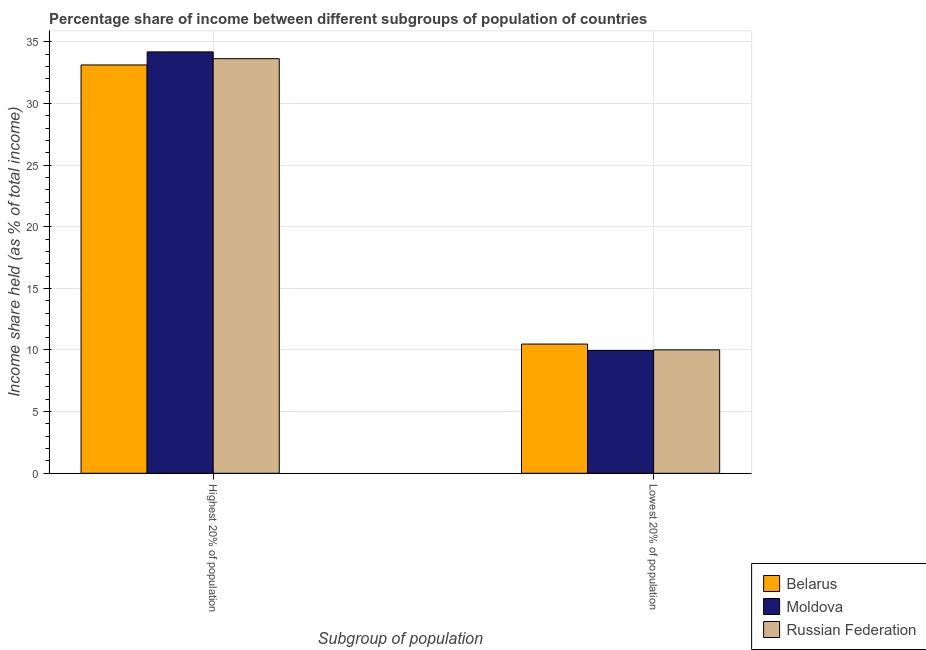How many different coloured bars are there?
Ensure brevity in your answer.  3. How many bars are there on the 1st tick from the left?
Your answer should be compact. 3. What is the label of the 1st group of bars from the left?
Ensure brevity in your answer.  Highest 20% of population. What is the income share held by highest 20% of the population in Moldova?
Your answer should be compact. 34.18. Across all countries, what is the maximum income share held by lowest 20% of the population?
Ensure brevity in your answer.  10.48. Across all countries, what is the minimum income share held by highest 20% of the population?
Make the answer very short. 33.12. In which country was the income share held by lowest 20% of the population maximum?
Make the answer very short. Belarus. In which country was the income share held by highest 20% of the population minimum?
Make the answer very short. Belarus. What is the total income share held by highest 20% of the population in the graph?
Keep it short and to the point. 100.93. What is the difference between the income share held by highest 20% of the population in Russian Federation and that in Moldova?
Provide a short and direct response. -0.55. What is the difference between the income share held by lowest 20% of the population in Russian Federation and the income share held by highest 20% of the population in Moldova?
Offer a very short reply. -24.17. What is the average income share held by lowest 20% of the population per country?
Offer a terse response. 10.15. What is the difference between the income share held by lowest 20% of the population and income share held by highest 20% of the population in Russian Federation?
Provide a succinct answer. -23.62. In how many countries, is the income share held by lowest 20% of the population greater than 13 %?
Provide a succinct answer. 0. What is the ratio of the income share held by highest 20% of the population in Russian Federation to that in Moldova?
Offer a very short reply. 0.98. Is the income share held by lowest 20% of the population in Russian Federation less than that in Belarus?
Offer a terse response. Yes. In how many countries, is the income share held by highest 20% of the population greater than the average income share held by highest 20% of the population taken over all countries?
Ensure brevity in your answer.  1. What does the 3rd bar from the left in Highest 20% of population represents?
Your response must be concise. Russian Federation. What does the 2nd bar from the right in Highest 20% of population represents?
Your response must be concise. Moldova. How many countries are there in the graph?
Keep it short and to the point. 3. Are the values on the major ticks of Y-axis written in scientific E-notation?
Keep it short and to the point. No. Does the graph contain any zero values?
Keep it short and to the point. No. Does the graph contain grids?
Offer a terse response. Yes. Where does the legend appear in the graph?
Your answer should be compact. Bottom right. How are the legend labels stacked?
Your answer should be compact. Vertical. What is the title of the graph?
Ensure brevity in your answer.  Percentage share of income between different subgroups of population of countries. Does "Caribbean small states" appear as one of the legend labels in the graph?
Keep it short and to the point. No. What is the label or title of the X-axis?
Your answer should be compact. Subgroup of population. What is the label or title of the Y-axis?
Offer a terse response. Income share held (as % of total income). What is the Income share held (as % of total income) in Belarus in Highest 20% of population?
Offer a very short reply. 33.12. What is the Income share held (as % of total income) of Moldova in Highest 20% of population?
Your answer should be very brief. 34.18. What is the Income share held (as % of total income) in Russian Federation in Highest 20% of population?
Offer a terse response. 33.63. What is the Income share held (as % of total income) in Belarus in Lowest 20% of population?
Your answer should be very brief. 10.48. What is the Income share held (as % of total income) in Moldova in Lowest 20% of population?
Give a very brief answer. 9.96. What is the Income share held (as % of total income) of Russian Federation in Lowest 20% of population?
Make the answer very short. 10.01. Across all Subgroup of population, what is the maximum Income share held (as % of total income) of Belarus?
Provide a succinct answer. 33.12. Across all Subgroup of population, what is the maximum Income share held (as % of total income) in Moldova?
Keep it short and to the point. 34.18. Across all Subgroup of population, what is the maximum Income share held (as % of total income) of Russian Federation?
Your answer should be very brief. 33.63. Across all Subgroup of population, what is the minimum Income share held (as % of total income) in Belarus?
Provide a short and direct response. 10.48. Across all Subgroup of population, what is the minimum Income share held (as % of total income) of Moldova?
Keep it short and to the point. 9.96. Across all Subgroup of population, what is the minimum Income share held (as % of total income) in Russian Federation?
Your answer should be compact. 10.01. What is the total Income share held (as % of total income) of Belarus in the graph?
Your answer should be very brief. 43.6. What is the total Income share held (as % of total income) in Moldova in the graph?
Provide a succinct answer. 44.14. What is the total Income share held (as % of total income) of Russian Federation in the graph?
Give a very brief answer. 43.64. What is the difference between the Income share held (as % of total income) in Belarus in Highest 20% of population and that in Lowest 20% of population?
Ensure brevity in your answer.  22.64. What is the difference between the Income share held (as % of total income) of Moldova in Highest 20% of population and that in Lowest 20% of population?
Give a very brief answer. 24.22. What is the difference between the Income share held (as % of total income) of Russian Federation in Highest 20% of population and that in Lowest 20% of population?
Provide a short and direct response. 23.62. What is the difference between the Income share held (as % of total income) of Belarus in Highest 20% of population and the Income share held (as % of total income) of Moldova in Lowest 20% of population?
Offer a terse response. 23.16. What is the difference between the Income share held (as % of total income) in Belarus in Highest 20% of population and the Income share held (as % of total income) in Russian Federation in Lowest 20% of population?
Keep it short and to the point. 23.11. What is the difference between the Income share held (as % of total income) in Moldova in Highest 20% of population and the Income share held (as % of total income) in Russian Federation in Lowest 20% of population?
Keep it short and to the point. 24.17. What is the average Income share held (as % of total income) in Belarus per Subgroup of population?
Keep it short and to the point. 21.8. What is the average Income share held (as % of total income) in Moldova per Subgroup of population?
Provide a succinct answer. 22.07. What is the average Income share held (as % of total income) in Russian Federation per Subgroup of population?
Provide a succinct answer. 21.82. What is the difference between the Income share held (as % of total income) in Belarus and Income share held (as % of total income) in Moldova in Highest 20% of population?
Keep it short and to the point. -1.06. What is the difference between the Income share held (as % of total income) in Belarus and Income share held (as % of total income) in Russian Federation in Highest 20% of population?
Provide a short and direct response. -0.51. What is the difference between the Income share held (as % of total income) in Moldova and Income share held (as % of total income) in Russian Federation in Highest 20% of population?
Give a very brief answer. 0.55. What is the difference between the Income share held (as % of total income) of Belarus and Income share held (as % of total income) of Moldova in Lowest 20% of population?
Offer a terse response. 0.52. What is the difference between the Income share held (as % of total income) of Belarus and Income share held (as % of total income) of Russian Federation in Lowest 20% of population?
Provide a succinct answer. 0.47. What is the ratio of the Income share held (as % of total income) in Belarus in Highest 20% of population to that in Lowest 20% of population?
Your answer should be compact. 3.16. What is the ratio of the Income share held (as % of total income) in Moldova in Highest 20% of population to that in Lowest 20% of population?
Keep it short and to the point. 3.43. What is the ratio of the Income share held (as % of total income) in Russian Federation in Highest 20% of population to that in Lowest 20% of population?
Give a very brief answer. 3.36. What is the difference between the highest and the second highest Income share held (as % of total income) in Belarus?
Keep it short and to the point. 22.64. What is the difference between the highest and the second highest Income share held (as % of total income) of Moldova?
Keep it short and to the point. 24.22. What is the difference between the highest and the second highest Income share held (as % of total income) of Russian Federation?
Make the answer very short. 23.62. What is the difference between the highest and the lowest Income share held (as % of total income) of Belarus?
Your response must be concise. 22.64. What is the difference between the highest and the lowest Income share held (as % of total income) in Moldova?
Give a very brief answer. 24.22. What is the difference between the highest and the lowest Income share held (as % of total income) in Russian Federation?
Provide a short and direct response. 23.62. 